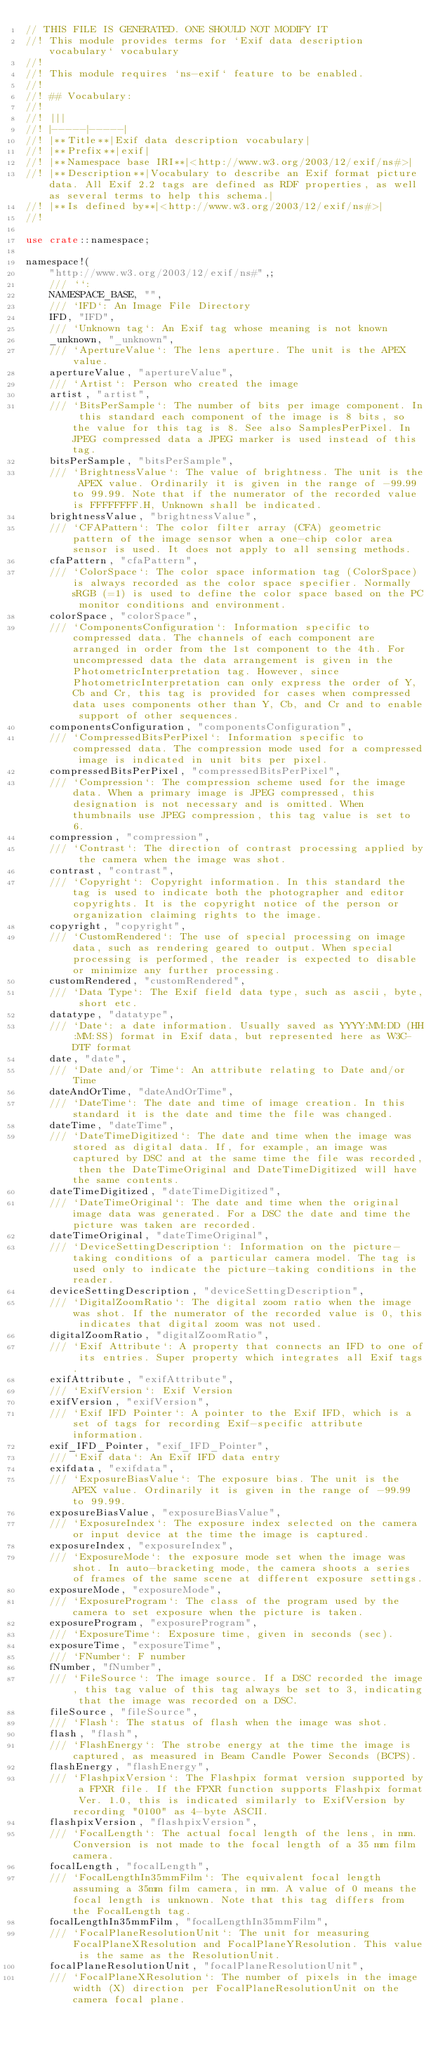<code> <loc_0><loc_0><loc_500><loc_500><_Rust_>// THIS FILE IS GENERATED. ONE SHOULD NOT MODIFY IT
//! This module provides terms for `Exif data description vocabulary` vocabulary
//!
//! This module requires `ns-exif` feature to be enabled.
//!
//! ## Vocabulary:
//!
//! |||
//! |-----|-----|
//! |**Title**|Exif data description vocabulary|
//! |**Prefix**|exif|
//! |**Namespace base IRI**|<http://www.w3.org/2003/12/exif/ns#>|
//! |**Description**|Vocabulary to describe an Exif format picture data. All Exif 2.2 tags are defined as RDF properties, as well as several terms to help this schema.|
//! |**Is defined by**|<http://www.w3.org/2003/12/exif/ns#>|
//!

use crate::namespace;

namespace!(
    "http://www.w3.org/2003/12/exif/ns#",;
    /// ``: 
    NAMESPACE_BASE, "",
    /// `IFD`: An Image File Directory
    IFD, "IFD",
    /// `Unknown tag`: An Exif tag whose meaning is not known
    _unknown, "_unknown",
    /// `ApertureValue`: The lens aperture. The unit is the APEX value.
    apertureValue, "apertureValue",
    /// `Artist`: Person who created the image
    artist, "artist",
    /// `BitsPerSample`: The number of bits per image component. In this standard each component of the image is 8 bits, so the value for this tag is 8. See also SamplesPerPixel. In JPEG compressed data a JPEG marker is used instead of this tag.
    bitsPerSample, "bitsPerSample",
    /// `BrightnessValue`: The value of brightness. The unit is the APEX value. Ordinarily it is given in the range of -99.99 to 99.99. Note that if the numerator of the recorded value is FFFFFFFF.H, Unknown shall be indicated.
    brightnessValue, "brightnessValue",
    /// `CFAPattern`: The color filter array (CFA) geometric pattern of the image sensor when a one-chip color area sensor is used. It does not apply to all sensing methods.
    cfaPattern, "cfaPattern",
    /// `ColorSpace`: The color space information tag (ColorSpace) is always recorded as the color space specifier. Normally sRGB (=1) is used to define the color space based on the PC monitor conditions and environment.
    colorSpace, "colorSpace",
    /// `ComponentsConfiguration`: Information specific to compressed data. The channels of each component are arranged in order from the 1st component to the 4th. For uncompressed data the data arrangement is given in the PhotometricInterpretation tag. However, since PhotometricInterpretation can only express the order of Y,Cb and Cr, this tag is provided for cases when compressed data uses components other than Y, Cb, and Cr and to enable support of other sequences.
    componentsConfiguration, "componentsConfiguration",
    /// `CompressedBitsPerPixel`: Information specific to compressed data. The compression mode used for a compressed image is indicated in unit bits per pixel.
    compressedBitsPerPixel, "compressedBitsPerPixel",
    /// `Compression`: The compression scheme used for the image data. When a primary image is JPEG compressed, this designation is not necessary and is omitted. When thumbnails use JPEG compression, this tag value is set to 6.
    compression, "compression",
    /// `Contrast`: The direction of contrast processing applied by the camera when the image was shot.
    contrast, "contrast",
    /// `Copyright`: Copyright information. In this standard the tag is used to indicate both the photographer and editor copyrights. It is the copyright notice of the person or organization claiming rights to the image.
    copyright, "copyright",
    /// `CustomRendered`: The use of special processing on image data, such as rendering geared to output. When special processing is performed, the reader is expected to disable or minimize any further processing.
    customRendered, "customRendered",
    /// `Data Type`: The Exif field data type, such as ascii, byte, short etc.
    datatype, "datatype",
    /// `Date`: a date information. Usually saved as YYYY:MM:DD (HH:MM:SS) format in Exif data, but represented here as W3C-DTF format
    date, "date",
    /// `Date and/or Time`: An attribute relating to Date and/or Time
    dateAndOrTime, "dateAndOrTime",
    /// `DateTime`: The date and time of image creation. In this standard it is the date and time the file was changed.
    dateTime, "dateTime",
    /// `DateTimeDigitized`: The date and time when the image was stored as digital data. If, for example, an image was captured by DSC and at the same time the file was recorded, then the DateTimeOriginal and DateTimeDigitized will have the same contents.
    dateTimeDigitized, "dateTimeDigitized",
    /// `DateTimeOriginal`: The date and time when the original image data was generated. For a DSC the date and time the picture was taken are recorded.
    dateTimeOriginal, "dateTimeOriginal",
    /// `DeviceSettingDescription`: Information on the picture-taking conditions of a particular camera model. The tag is used only to indicate the picture-taking conditions in the reader.
    deviceSettingDescription, "deviceSettingDescription",
    /// `DigitalZoomRatio`: The digital zoom ratio when the image was shot. If the numerator of the recorded value is 0, this indicates that digital zoom was not used.
    digitalZoomRatio, "digitalZoomRatio",
    /// `Exif Attribute`: A property that connects an IFD to one of its entries. Super property which integrates all Exif tags.
    exifAttribute, "exifAttribute",
    /// `ExifVersion`: Exif Version
    exifVersion, "exifVersion",
    /// `Exif IFD Pointer`: A pointer to the Exif IFD, which is a set of tags for recording Exif-specific attribute information.
    exif_IFD_Pointer, "exif_IFD_Pointer",
    /// `Exif data`: An Exif IFD data entry
    exifdata, "exifdata",
    /// `ExposureBiasValue`: The exposure bias. The unit is the APEX value. Ordinarily it is given in the range of -99.99 to 99.99.
    exposureBiasValue, "exposureBiasValue",
    /// `ExposureIndex`: The exposure index selected on the camera or input device at the time the image is captured.
    exposureIndex, "exposureIndex",
    /// `ExposureMode`: the exposure mode set when the image was shot. In auto-bracketing mode, the camera shoots a series of frames of the same scene at different exposure settings.
    exposureMode, "exposureMode",
    /// `ExposureProgram`: The class of the program used by the camera to set exposure when the picture is taken.
    exposureProgram, "exposureProgram",
    /// `ExposureTime`: Exposure time, given in seconds (sec).
    exposureTime, "exposureTime",
    /// `FNumber`: F number
    fNumber, "fNumber",
    /// `FileSource`: The image source. If a DSC recorded the image, this tag value of this tag always be set to 3, indicating that the image was recorded on a DSC.
    fileSource, "fileSource",
    /// `Flash`: The status of flash when the image was shot.
    flash, "flash",
    /// `FlashEnergy`: The strobe energy at the time the image is captured, as measured in Beam Candle Power Seconds (BCPS).
    flashEnergy, "flashEnergy",
    /// `FlashpixVersion`: The Flashpix format version supported by a FPXR file. If the FPXR function supports Flashpix format Ver. 1.0, this is indicated similarly to ExifVersion by recording "0100" as 4-byte ASCII.
    flashpixVersion, "flashpixVersion",
    /// `FocalLength`: The actual focal length of the lens, in mm. Conversion is not made to the focal length of a 35 mm film camera.
    focalLength, "focalLength",
    /// `FocalLengthIn35mmFilm`: The equivalent focal length assuming a 35mm film camera, in mm. A value of 0 means the focal length is unknown. Note that this tag differs from the FocalLength tag.
    focalLengthIn35mmFilm, "focalLengthIn35mmFilm",
    /// `FocalPlaneResolutionUnit`: The unit for measuring FocalPlaneXResolution and FocalPlaneYResolution. This value is the same as the ResolutionUnit.
    focalPlaneResolutionUnit, "focalPlaneResolutionUnit",
    /// `FocalPlaneXResolution`: The number of pixels in the image width (X) direction per FocalPlaneResolutionUnit on the camera focal plane.</code> 